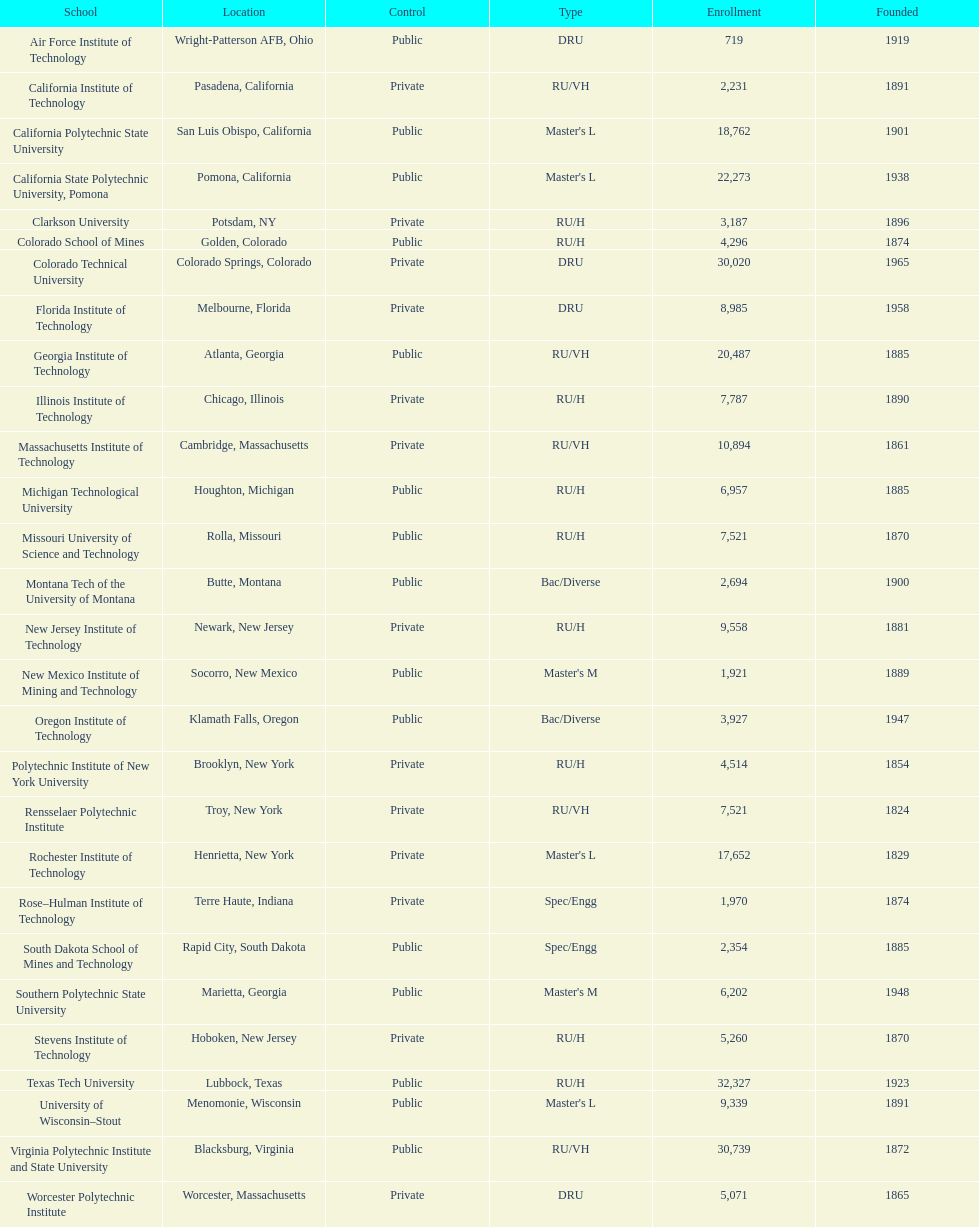What is the distinction in registration between the top 2 schools mentioned in the table? 1512. 